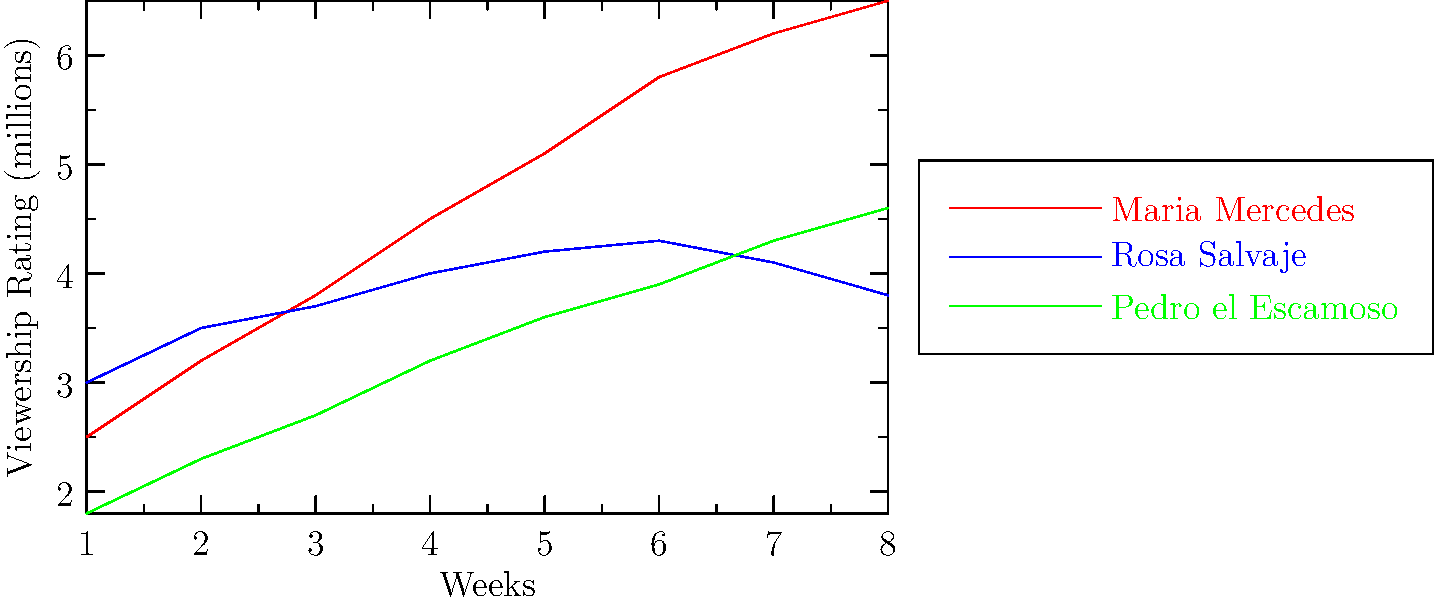Based on the line graph showing viewership ratings for three popular telenovelas in Kenya over 8 weeks, which telenovela experienced the most consistent growth in viewership, and what was its approximate rating increase from Week 1 to Week 8? To answer this question, we need to analyze the trends for each telenovela:

1. Maria Mercedes (red line):
   - Starts at 2.5 million viewers
   - Ends at 6.5 million viewers
   - Shows consistent upward growth

2. Rosa Salvaje (blue line):
   - Starts at 3.0 million viewers
   - Peaks around Week 6 and then declines
   - Shows inconsistent growth

3. Pedro el Escamoso (green line):
   - Starts at 1.8 million viewers
   - Ends at 4.6 million viewers
   - Shows consistent upward growth

Among these, Maria Mercedes and Pedro el Escamoso both show consistent growth. However, Maria Mercedes has a steeper slope, indicating more rapid growth.

To calculate the rating increase for Maria Mercedes:
- Week 1 rating: 2.5 million
- Week 8 rating: 6.5 million
- Increase: $6.5 - 2.5 = 4$ million

Therefore, Maria Mercedes experienced the most consistent growth with an approximate rating increase of 4 million viewers from Week 1 to Week 8.
Answer: Maria Mercedes, 4 million viewers 